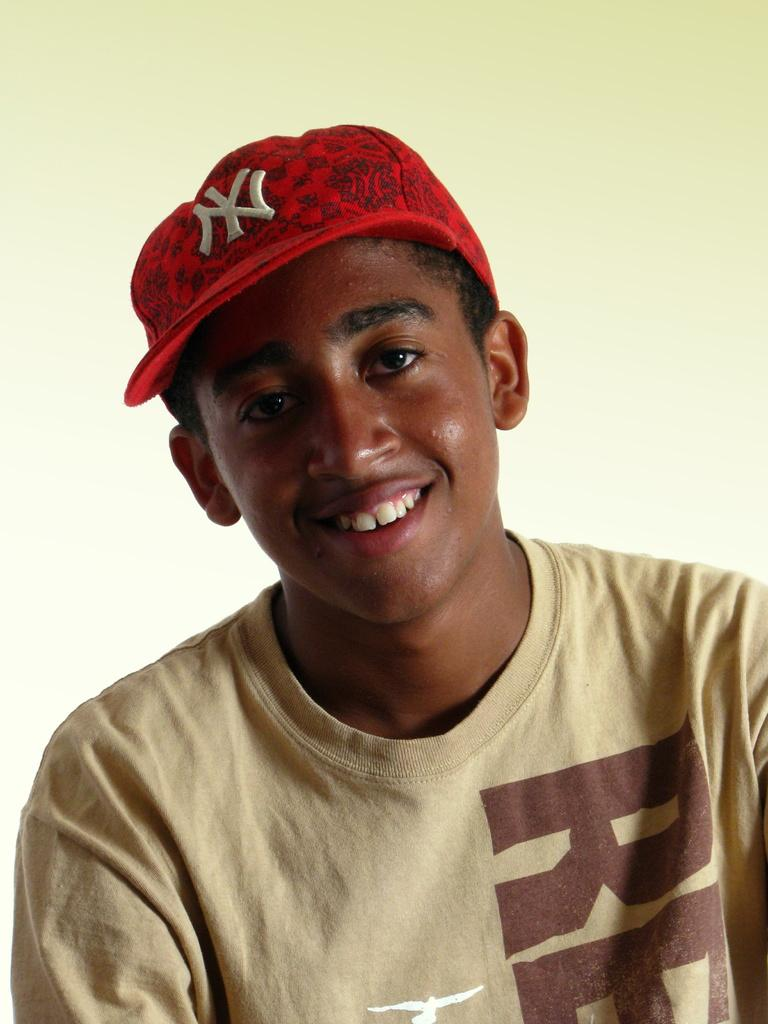What is present in the image? There is a person in the image. Can you describe the person's attire? The person is wearing a cap. What can be seen behind the person? There is a background visible in the image. What type of salt can be seen on the person's cap in the image? There is no salt present on the person's cap in the image. What sign is the person holding in the image? There is no sign visible in the image. 